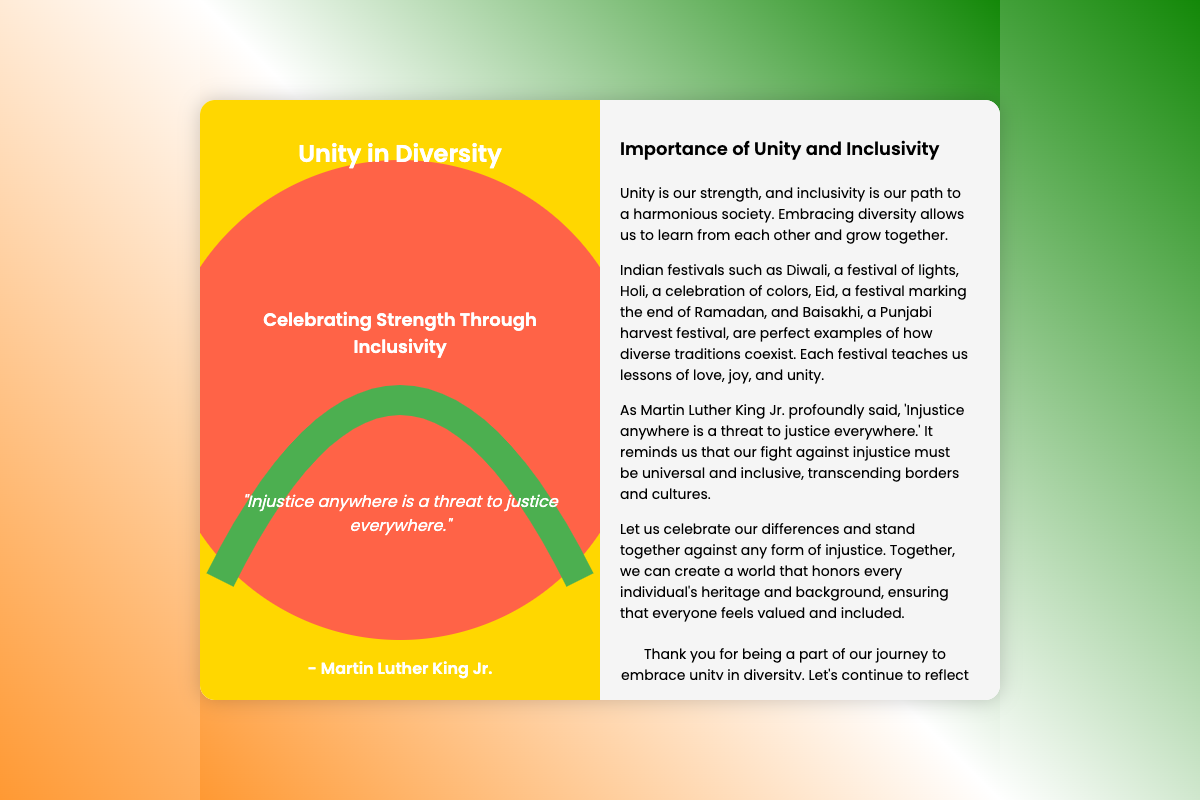What is the title of the greeting card? The title of the greeting card is prominently displayed on the front cover.
Answer: Unity in Diversity Who is quoted in the card? The quote on the card is attributed to a well-known civil rights leader.
Answer: Martin Luther King Jr What does the quote say? The quote is a significant message about justice and its universal importance.
Answer: "Injustice anywhere is a threat to justice everywhere." Which Indian festival is mentioned as a festival of lights? This particular festival is celebrated to symbolize victory of light over darkness.
Answer: Diwali What colors are used in the card's background? The background features a gradient blend of three colors symbolizing unity and positivity.
Answer: Orange, white, green What is the key theme addressed in the back cover? The back cover elaborates on an important societal principle that fosters cohesion among people.
Answer: Unity and Inclusivity How does the card suggest we treat diversity? The card emphasizes a mindset that embraces differences and encourages community spirit.
Answer: Celebrate our differences What does the card thank the reader for? The card acknowledges the reader's support and participation in a collective effort.
Answer: Being a part of our journey to embrace unity in diversity Which festival is mentioned as a celebration of colors? This festival involves playful activities and signifies the arrival of spring.
Answer: Holi 